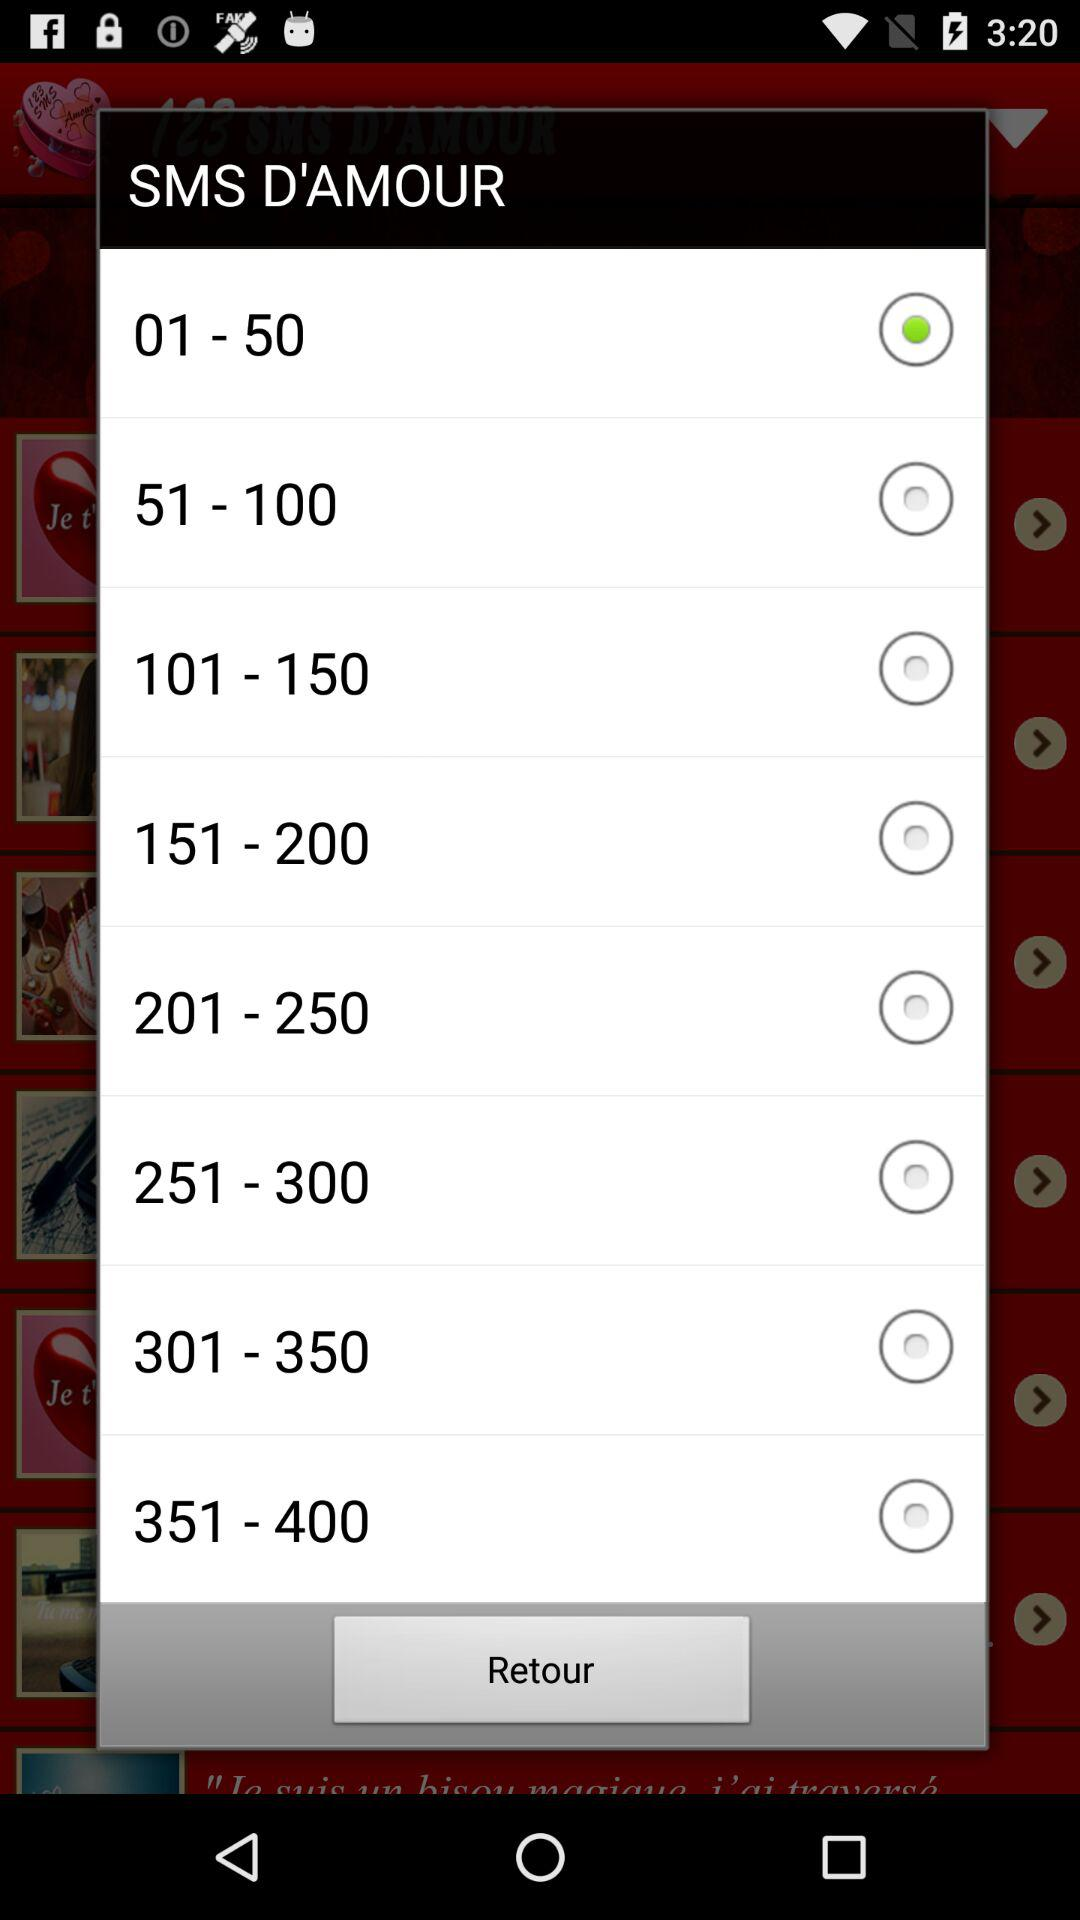What is the highest range? The highest range is 351-400. 